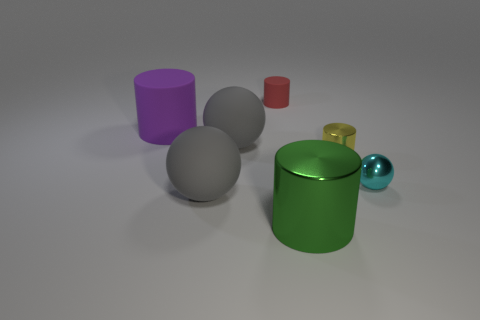Subtract 1 cylinders. How many cylinders are left? 3 Add 2 tiny green metal cubes. How many objects exist? 9 Subtract all cylinders. How many objects are left? 3 Subtract 0 purple blocks. How many objects are left? 7 Subtract all tiny shiny cylinders. Subtract all big green shiny objects. How many objects are left? 5 Add 5 small cylinders. How many small cylinders are left? 7 Add 6 big gray rubber objects. How many big gray rubber objects exist? 8 